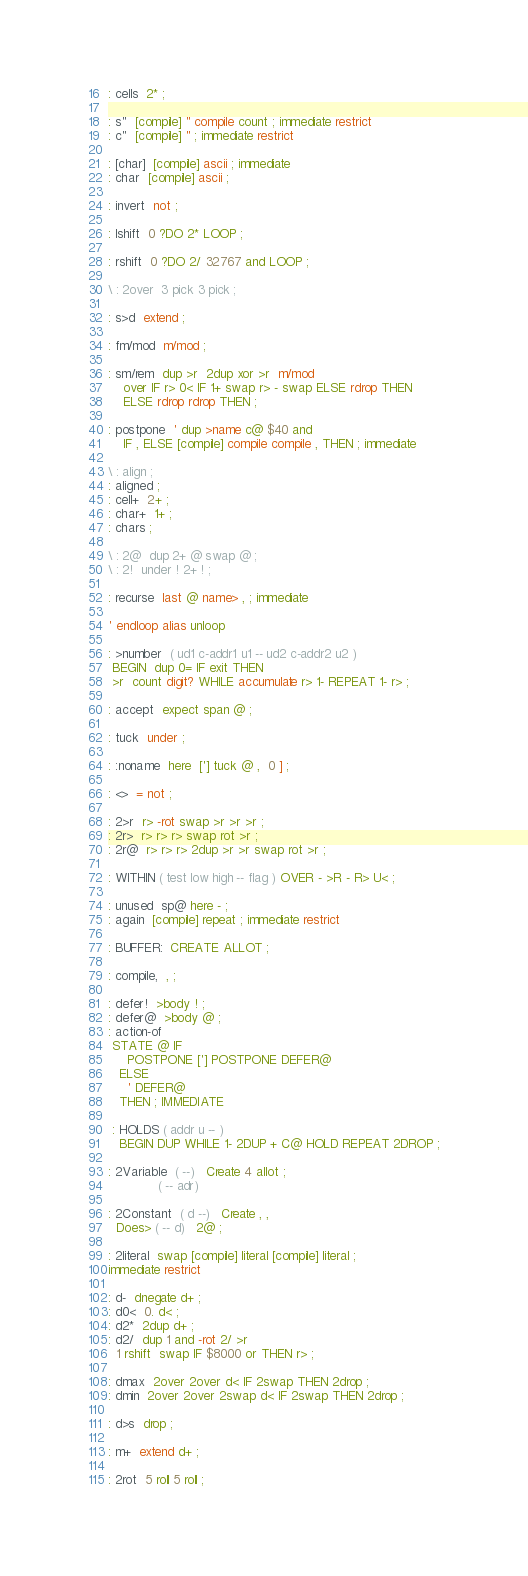<code> <loc_0><loc_0><loc_500><loc_500><_Forth_>
: cells  2* ;

: s"  [compile] " compile count ; immediate restrict
: c"  [compile] " ; immediate restrict

: [char]  [compile] ascii ; immediate
: char  [compile] ascii ;

: invert  not ;

: lshift  0 ?DO 2* LOOP ;

: rshift  0 ?DO 2/ 32767 and LOOP ;

\ : 2over  3 pick 3 pick ;

: s>d  extend ;

: fm/mod  m/mod ;

: sm/rem  dup >r  2dup xor >r  m/mod
    over IF r> 0< IF 1+ swap r> - swap ELSE rdrop THEN
    ELSE rdrop rdrop THEN ;

: postpone  ' dup >name c@ $40 and
    IF , ELSE [compile] compile compile , THEN ; immediate

\ : align ;
: aligned ;
: cell+  2+ ;
: char+  1+ ;
: chars ;

\ : 2@  dup 2+ @ swap @ ;
\ : 2!  under ! 2+ ! ;

: recurse  last @ name> , ; immediate

' endloop alias unloop

: >number  ( ud1 c-addr1 u1 -- ud2 c-addr2 u2 )
 BEGIN  dup 0= IF exit THEN
 >r  count digit? WHILE accumulate r> 1- REPEAT 1- r> ;

: accept  expect span @ ;

: tuck  under ;

: :noname  here  ['] tuck @ ,  0 ] ;

: <>  = not ;

: 2>r  r> -rot swap >r >r >r ;
: 2r>  r> r> r> swap rot >r ;
: 2r@  r> r> r> 2dup >r >r swap rot >r ;

: WITHIN ( test low high -- flag ) OVER - >R - R> U< ;

: unused  sp@ here - ;
: again  [compile] repeat ; immediate restrict

: BUFFER:  CREATE ALLOT ;

: compile,  , ;

: defer!  >body ! ;
: defer@  >body @ ;
: action-of
 STATE @ IF
     POSTPONE ['] POSTPONE DEFER@
   ELSE
     ' DEFER@
   THEN ; IMMEDIATE

 : HOLDS ( addr u -- )
   BEGIN DUP WHILE 1- 2DUP + C@ HOLD REPEAT 2DROP ;

: 2Variable  ( --)   Create 4 allot ;
             ( -- adr)

: 2Constant  ( d --)   Create , ,
  Does> ( -- d)   2@ ;

: 2literal  swap [compile] literal [compile] literal ;
immediate restrict

: d-  dnegate d+ ;
: d0<  0. d< ;
: d2*  2dup d+ ;
: d2/  dup 1 and -rot 2/ >r
  1 rshift  swap IF $8000 or THEN r> ;

: dmax  2over 2over d< IF 2swap THEN 2drop ;
: dmin  2over 2over 2swap d< IF 2swap THEN 2drop ;

: d>s  drop ;

: m+  extend d+ ;

: 2rot  5 roll 5 roll ;
</code> 